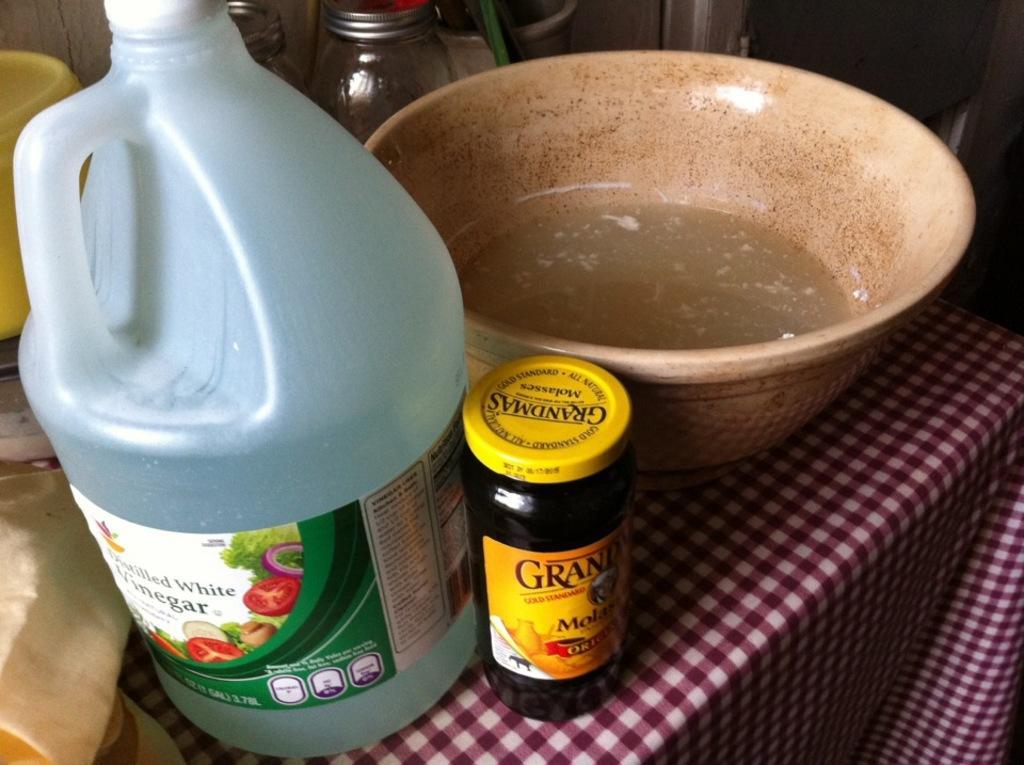In one or two sentences, can you explain what this image depicts? In this image we can see a blue color can, bottle, bowl and jars placed on the table. 